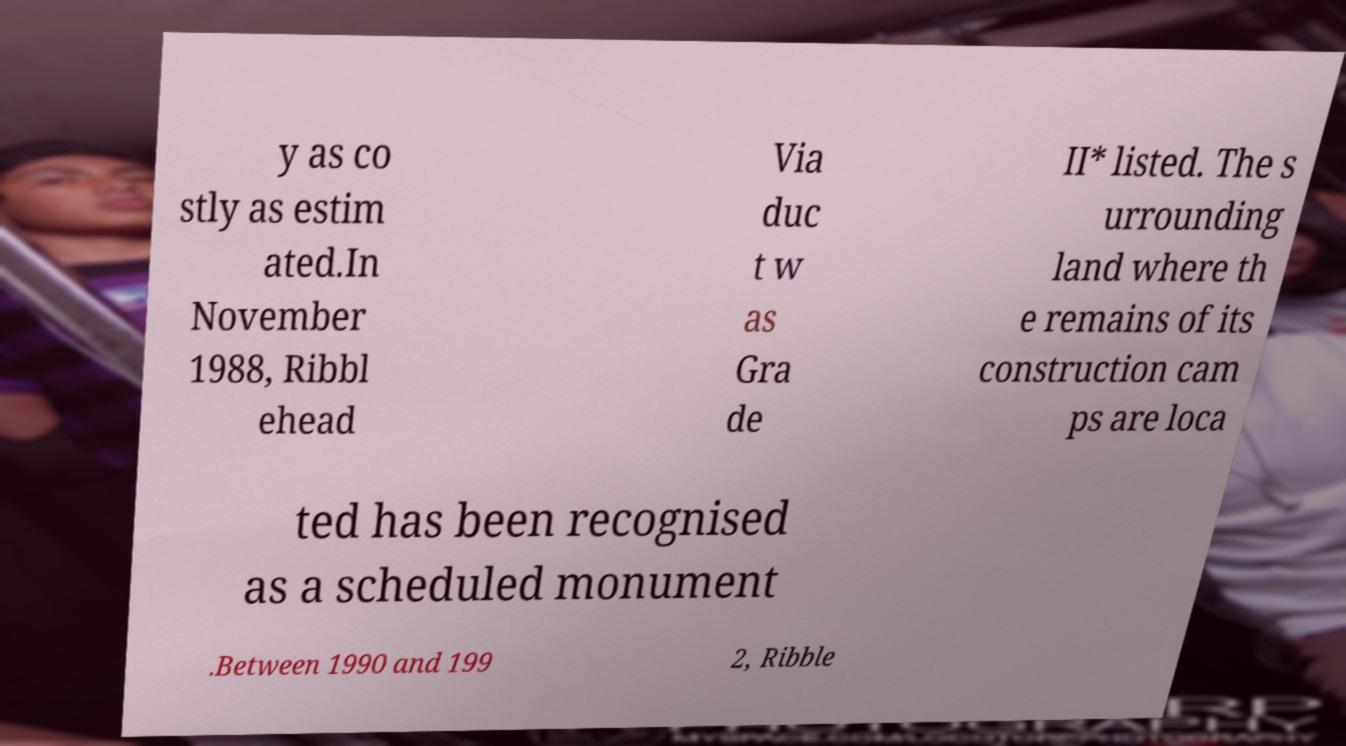There's text embedded in this image that I need extracted. Can you transcribe it verbatim? y as co stly as estim ated.In November 1988, Ribbl ehead Via duc t w as Gra de II* listed. The s urrounding land where th e remains of its construction cam ps are loca ted has been recognised as a scheduled monument .Between 1990 and 199 2, Ribble 